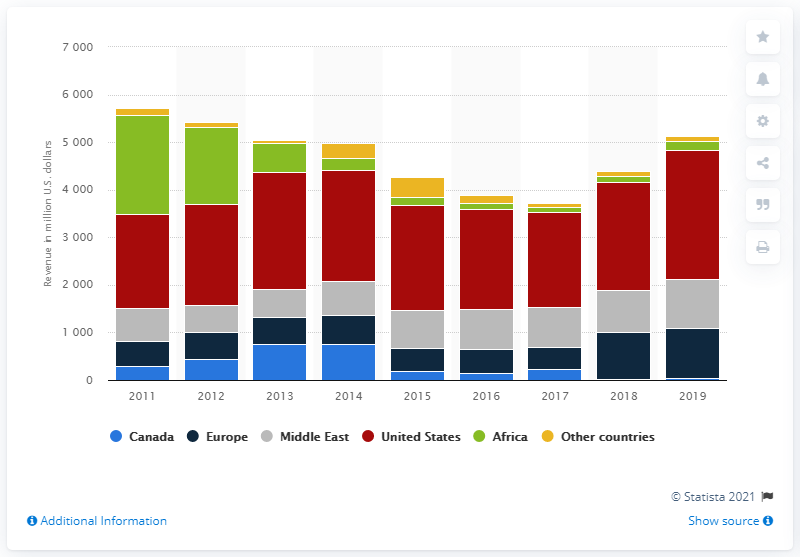Identify some key points in this picture. During the fiscal year of 2019, KBR Inc. generated a revenue of 2705 in the United States. 